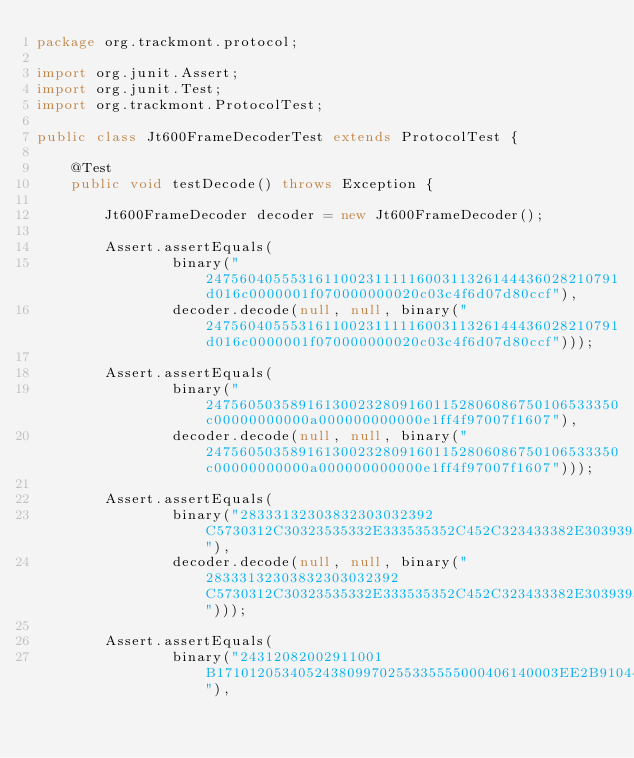<code> <loc_0><loc_0><loc_500><loc_500><_Java_>package org.trackmont.protocol;

import org.junit.Assert;
import org.junit.Test;
import org.trackmont.ProtocolTest;

public class Jt600FrameDecoderTest extends ProtocolTest {

    @Test
    public void testDecode() throws Exception {

        Jt600FrameDecoder decoder = new Jt600FrameDecoder();

        Assert.assertEquals(
                binary("2475604055531611002311111600311326144436028210791d016c0000001f070000000020c03c4f6d07d80ccf"),
                decoder.decode(null, null, binary("2475604055531611002311111600311326144436028210791d016c0000001f070000000020c03c4f6d07d80ccf")));

        Assert.assertEquals(
                binary("2475605035891613002328091601152806086750106533350c00000000000a000000000000e1ff4f97007f1607"),
                decoder.decode(null, null, binary("2475605035891613002328091601152806086750106533350c00000000000a000000000000e1ff4f97007f1607")));

        Assert.assertEquals(
                binary("28333132303832303032392C5730312C30323535332E333535352C452C323433382E303939372C532C412C3137313031322C3035333333392C302C382C32302C362C33312C352C32302C323029"),
                decoder.decode(null, null, binary("28333132303832303032392C5730312C30323535332E333535352C452C323433382E303939372C532C412C3137313031322C3035333333392C302C382C32302C362C33312C352C32302C323029")));

        Assert.assertEquals(
                binary("24312082002911001B171012053405243809970255335555000406140003EE2B91044D1F02"),</code> 